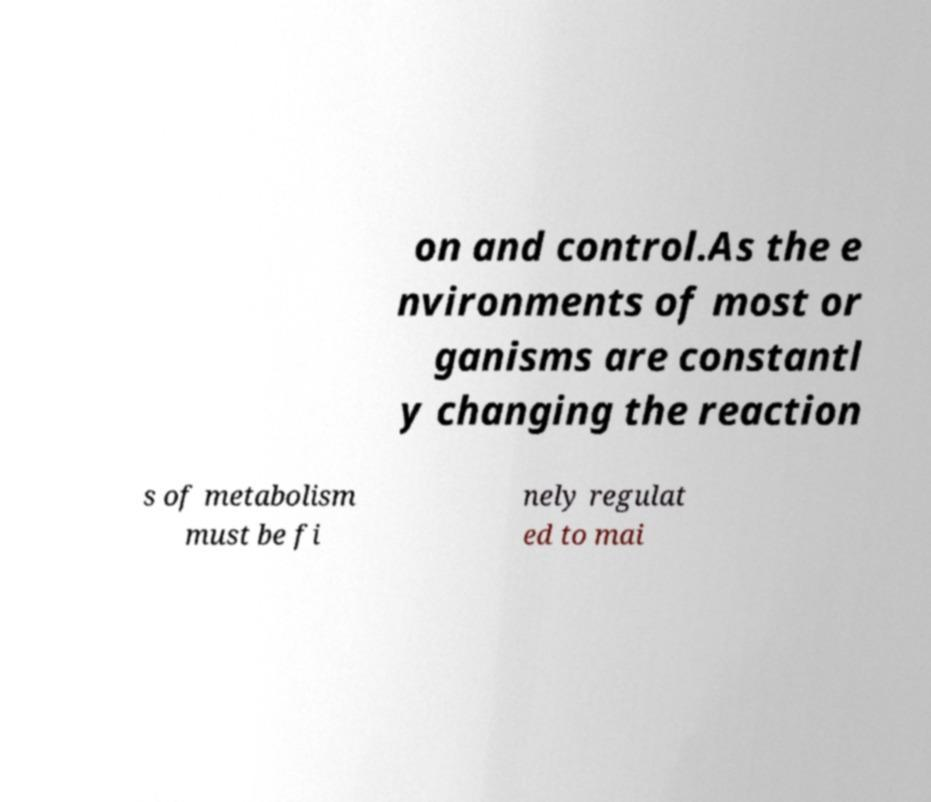Can you read and provide the text displayed in the image?This photo seems to have some interesting text. Can you extract and type it out for me? on and control.As the e nvironments of most or ganisms are constantl y changing the reaction s of metabolism must be fi nely regulat ed to mai 